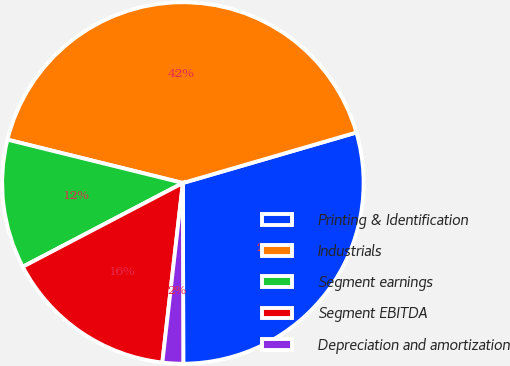Convert chart. <chart><loc_0><loc_0><loc_500><loc_500><pie_chart><fcel>Printing & Identification<fcel>Industrials<fcel>Segment earnings<fcel>Segment EBITDA<fcel>Depreciation and amortization<nl><fcel>29.47%<fcel>41.64%<fcel>11.53%<fcel>15.51%<fcel>1.85%<nl></chart> 